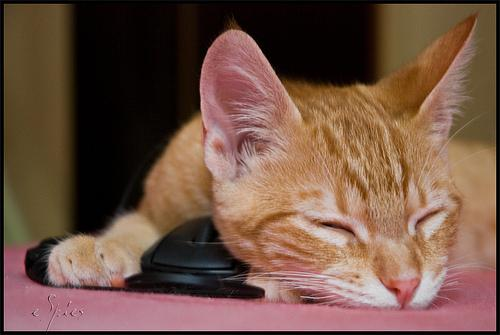Select 3 significant features or objects present in the image. A sleeping cat, a black computer mouse, and a pink blanket. Identify the main subject of the image and describe its position. A sleeping cat is positioned near the center, surrounded by various details like ears, eyes, and whiskers. In your own words, describe an interaction between the cat and the computer mouse. The cat appears to be resting, leaning on the black computer mouse, with its right paw surrounding the side of the mouse. 